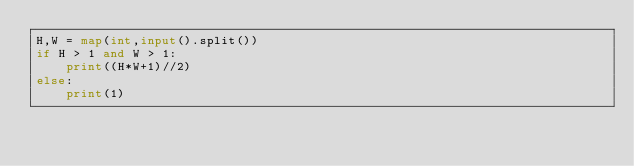Convert code to text. <code><loc_0><loc_0><loc_500><loc_500><_Python_>H,W = map(int,input().split())
if H > 1 and W > 1:
    print((H*W+1)//2)
else:
    print(1)</code> 